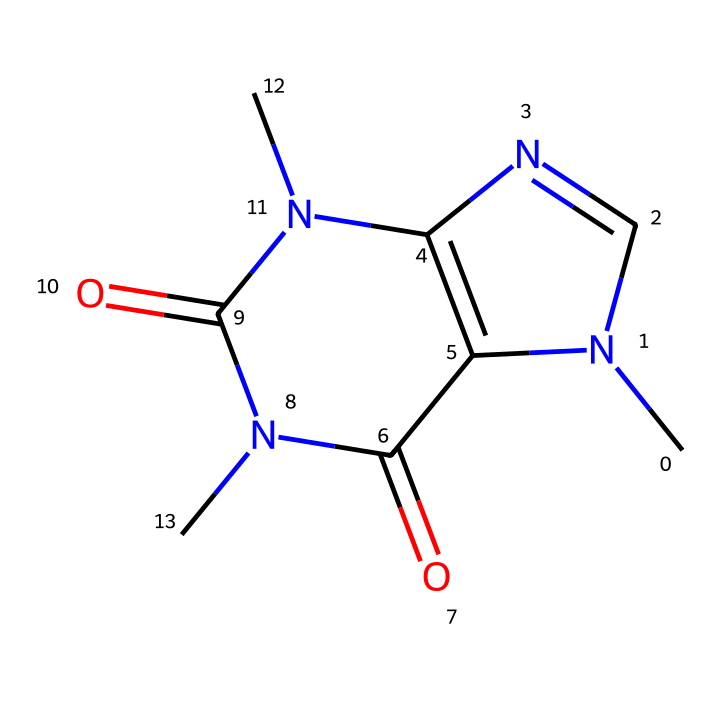What is the molecular formula of caffeine? To determine the molecular formula from the SMILES representation, we can count the number of each type of atom. The SMILES indicates there are 8 carbons (C), 10 hydrogens (H), and 4 nitrogens (N), and 2 oxygens (O). Combining these gives us C8H10N4O2.
Answer: C8H10N4O2 How many nitrogen atoms are in this molecule? By analyzing the SMILES structure, we can identify the nitrogen atoms. There are four nitrogen atoms present in the structure.
Answer: 4 What functional groups are present in caffeine? The SMILES structure shows the presence of two carbonyl groups (C=O) and nitrogen groups (N). This combination characterizes caffeine as an alkaloid.
Answer: carbonyl, amine What is the role of the nitrogen atoms in caffeine? The nitrogen atoms in caffeine contribute to its basic properties and pharmacological effects, influencing its ability to act as a stimulant. They form part of the heterocyclic ring, essential for binding to biological receptors.
Answer: stimulant What does the presence of oxygen atoms indicate about caffeine? The oxygen atoms in the structure suggest the presence of carbonyl functional groups, which influence the solubility and reactivity of caffeine, playing a key role in its physiological effects.
Answer: solubility How does the structure of caffeine contribute to its stimulant effect? Caffeine's structure, particularly the arrangement of nitrogen atoms in a fused ring system, allows it to block adenosine receptors in the brain. This leads to increased alertness and wakefulness, characteristic of its stimulant effects.
Answer: adenosine receptors 